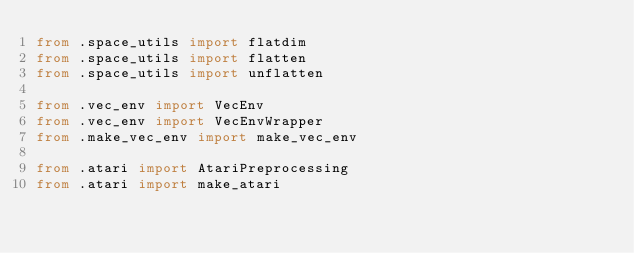<code> <loc_0><loc_0><loc_500><loc_500><_Python_>from .space_utils import flatdim
from .space_utils import flatten
from .space_utils import unflatten

from .vec_env import VecEnv
from .vec_env import VecEnvWrapper
from .make_vec_env import make_vec_env

from .atari import AtariPreprocessing
from .atari import make_atari
</code> 